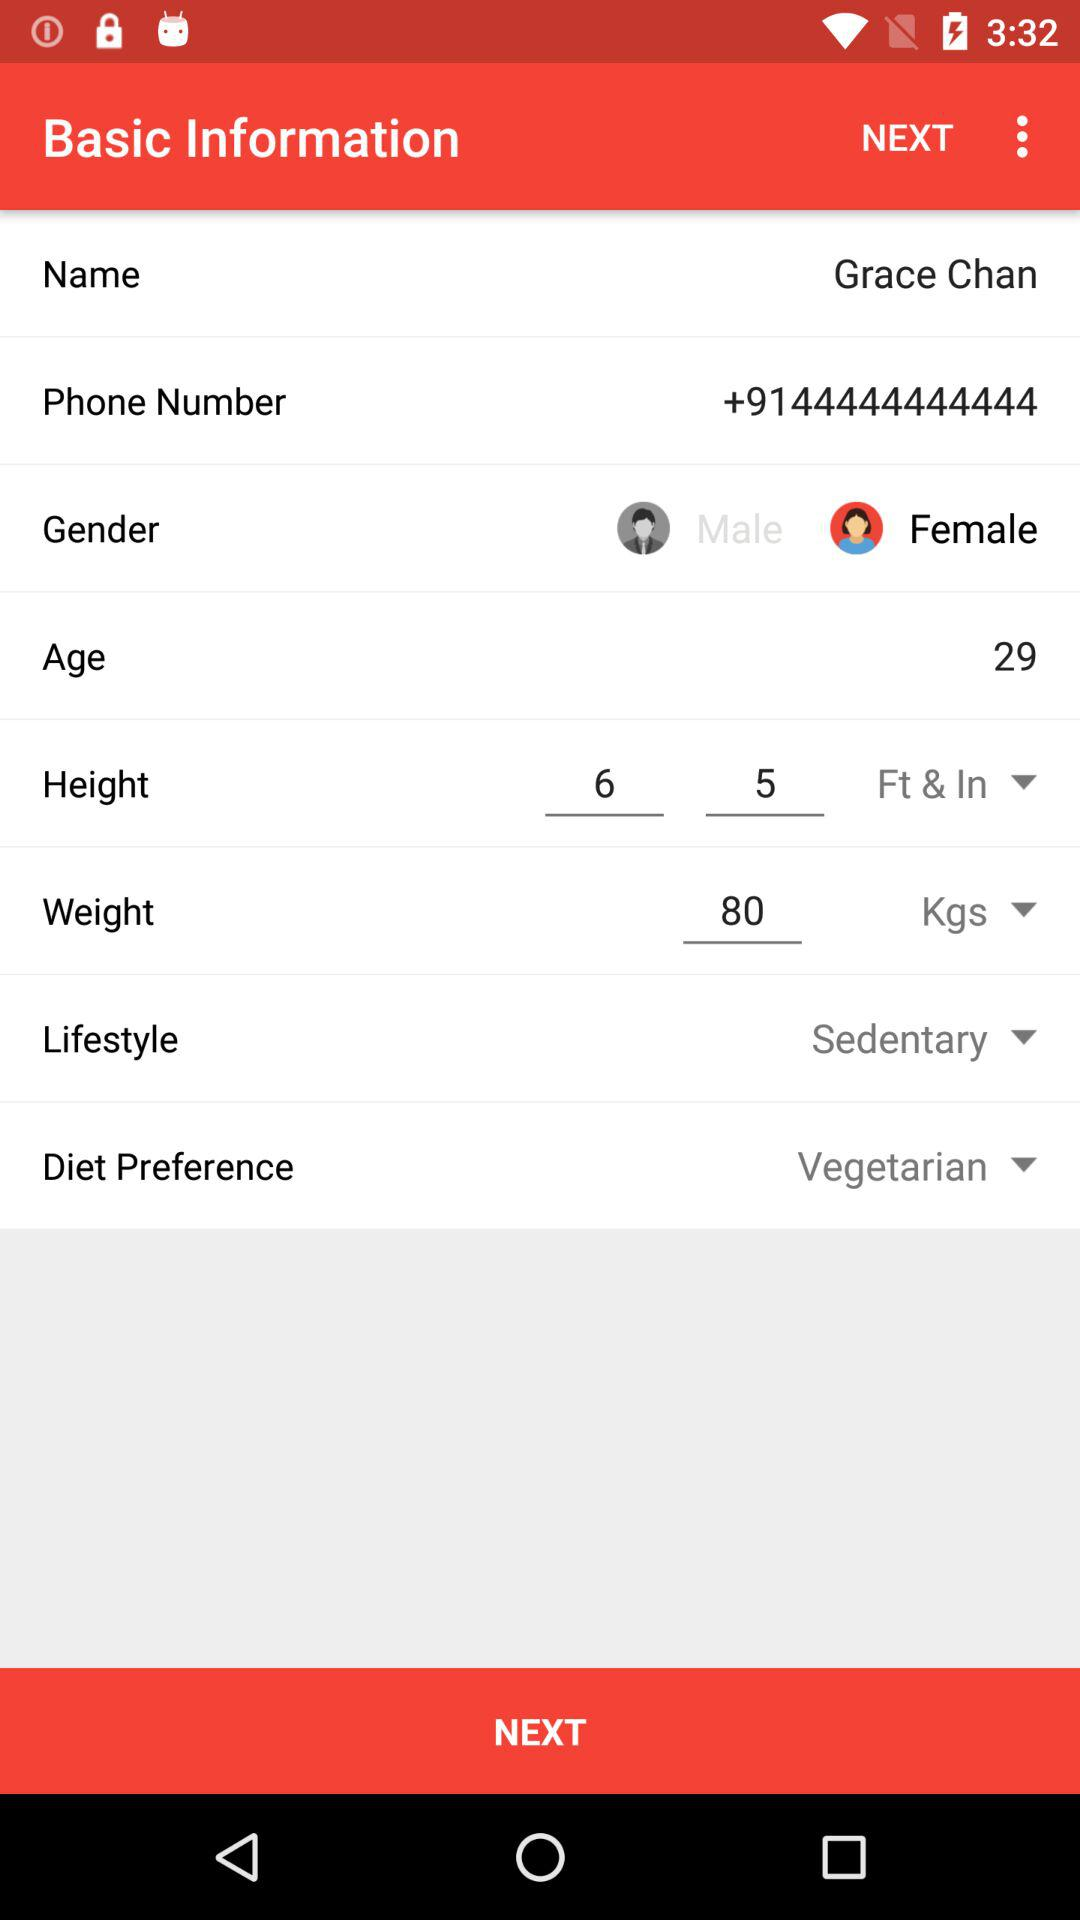What is the gender of Grace Chan? Grace Chan is a female. 